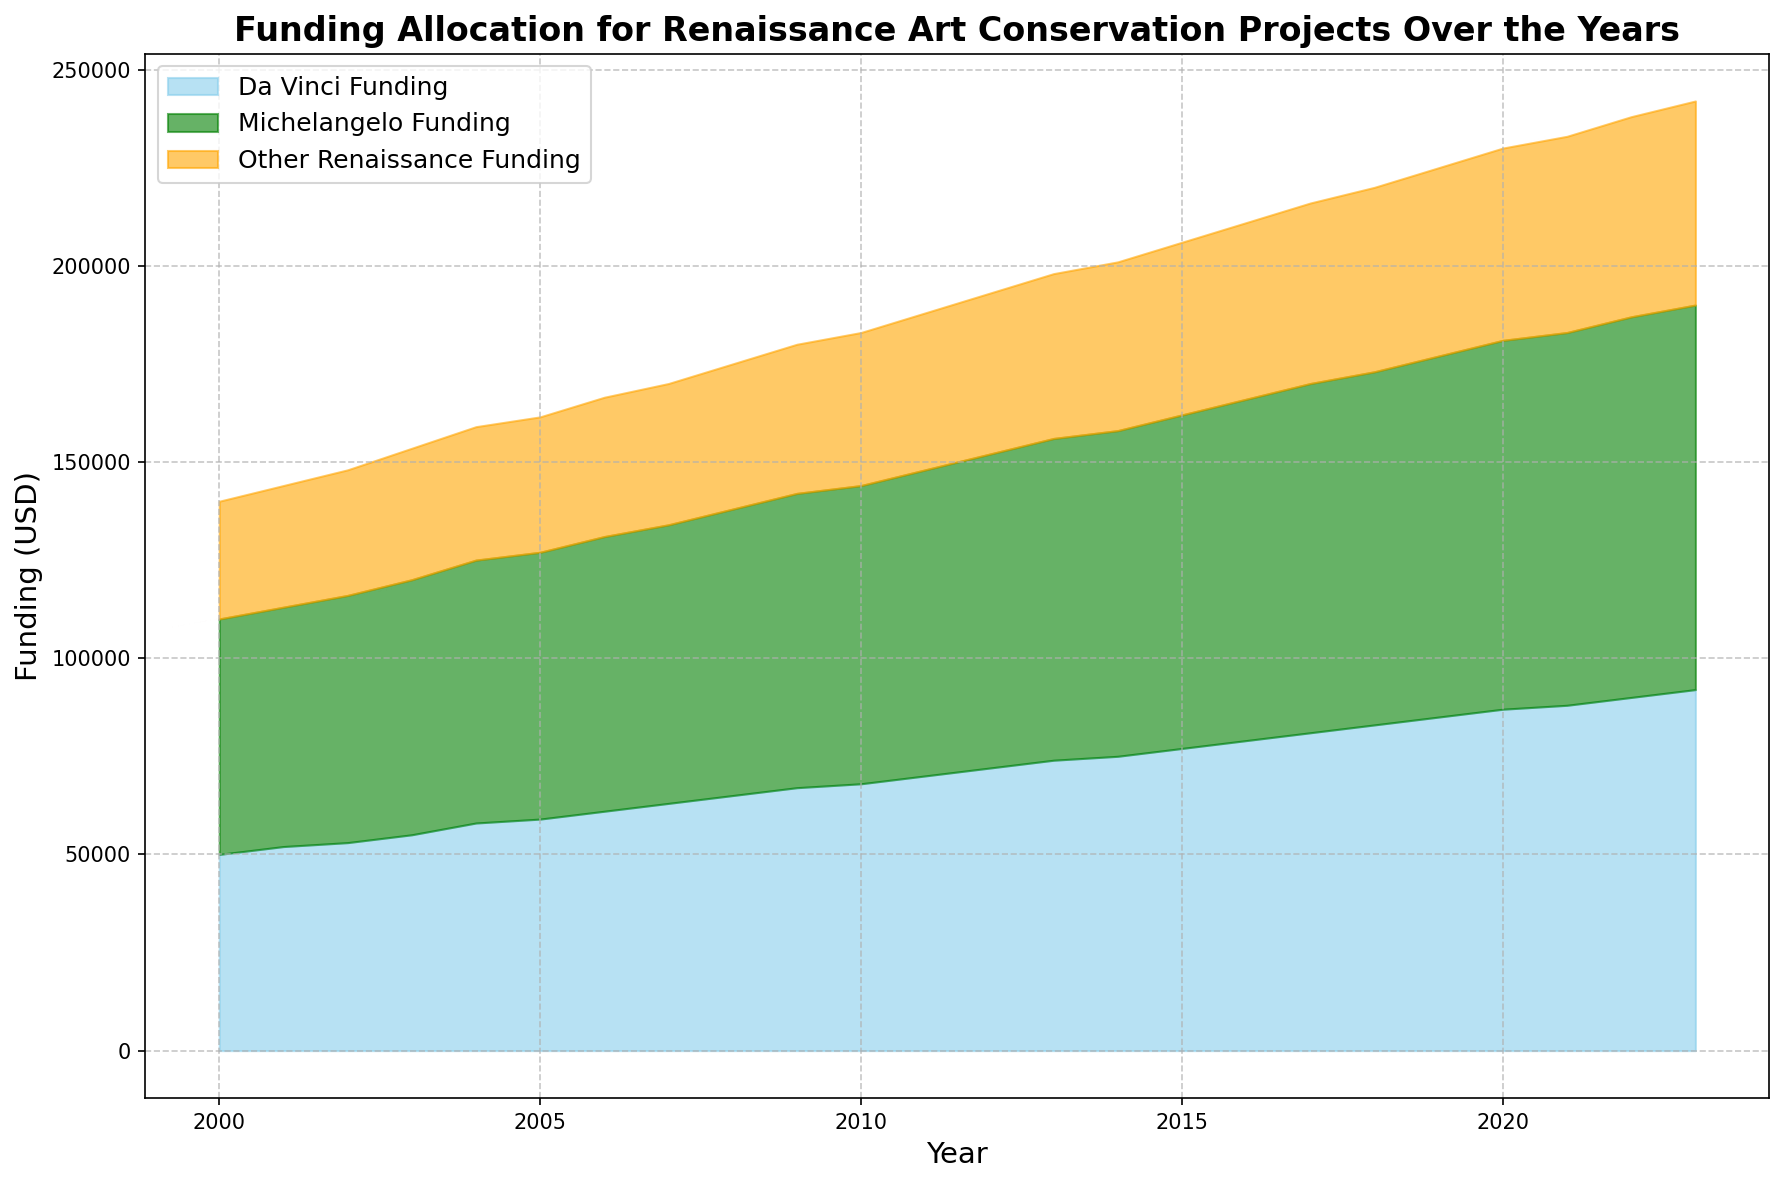What year had the highest total funding for Renaissance art conservation? To determine the year with the highest total funding, look for the point where the sum of Da Vinci, Michelangelo, and other Renaissance funding is the greatest. According to the area chart, the area size peaks in the year 2023.
Answer: 2023 In 2020, how much more funding did Michelangelo projects receive compared to Da Vinci projects? For 2020, Michelangelo funding was 94,000 USD and Da Vinci funding was 87,000 USD. The difference is calculated as 94,000 - 87,000.
Answer: 7,000 USD By how much did funding for Da Vinci projects increase from 2000 to 2023? Da Vinci funding in 2000 was 50,000 USD and in 2023 it was 92,000 USD. The increase is calculated as 92,000 - 50,000.
Answer: 42,000 USD Which funding category increased the most from 2000 to 2023? By comparing the funding amounts from 2000 to 2023, we notice that Da Vinci funding increased by 42,000 USD (92,000 - 50,000), Michelangelo funding increased by 38,000 USD (98,000 - 60,000), and other Renaissance funding increased by 22,000 USD (52,000 - 30,000). The largest increase is with Da Vinci funding.
Answer: Da Vinci What was the combined total funding for Renaissance art conservation projects in 2010? In 2010, Da Vinci funding was 68,000 USD, Michelangelo funding was 76,000 USD, and other Renaissance funding was 39,000 USD. The total is 68,000 + 76,000 + 39,000.
Answer: 183,000 USD Between which consecutive years did Da Vinci funding see the biggest increase? By looking at the years and funding amounts, we see the largest jump in Da Vinci funding from 2019 to 2020, where it increased from 85,000 USD to 87,000 USD (an increase of 2,000 USD).
Answer: 2019-2020 From 2000 to 2023, what was the average annual funding for Michelangelo projects? The funding amounts for Michelangelo projects are given for each year from 2000 to 2023. Calculate the sum of all Michelangelo funding for these years and then divide by the number of years (24).
Answer: 78,500 USD When comparing 2005 and 2015, how much did the total funding for other Renaissance projects change? In 2005, other Renaissance funding was 34,500 USD, and in 2015, it was 44,000 USD. The change is 44,000 - 34,500.
Answer: 9,500 USD What year had the smallest gap between Da Vinci and other Renaissance funding? By comparing the difference between Da Vinci funding and other Renaissance funding for each year, the smallest gap is found to be in 2000 (50,000 - 30,000 = 20,000).
Answer: 2000 How did the funding for Da Vinci projects and Michelangelo projects compare in 2012 in terms of visual height in the area chart? In 2012, the heights of the areas representing Da Vinci and Michelangelo funding are compared. Da Vinci funding is represented by a smaller area (visually shorter height) than Michelangelo funding.
Answer: Michelangelo funding was higher than Da Vinci funding 